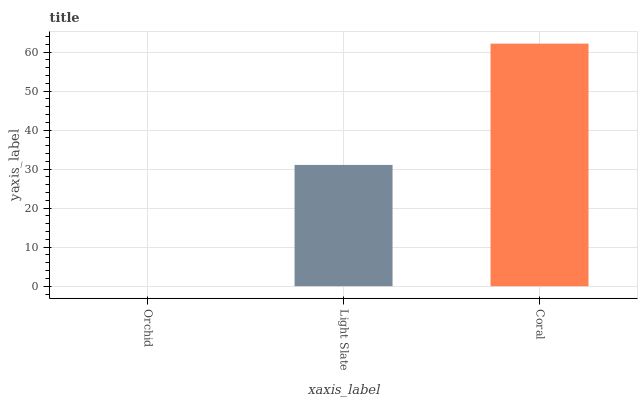Is Orchid the minimum?
Answer yes or no. Yes. Is Coral the maximum?
Answer yes or no. Yes. Is Light Slate the minimum?
Answer yes or no. No. Is Light Slate the maximum?
Answer yes or no. No. Is Light Slate greater than Orchid?
Answer yes or no. Yes. Is Orchid less than Light Slate?
Answer yes or no. Yes. Is Orchid greater than Light Slate?
Answer yes or no. No. Is Light Slate less than Orchid?
Answer yes or no. No. Is Light Slate the high median?
Answer yes or no. Yes. Is Light Slate the low median?
Answer yes or no. Yes. Is Coral the high median?
Answer yes or no. No. Is Orchid the low median?
Answer yes or no. No. 